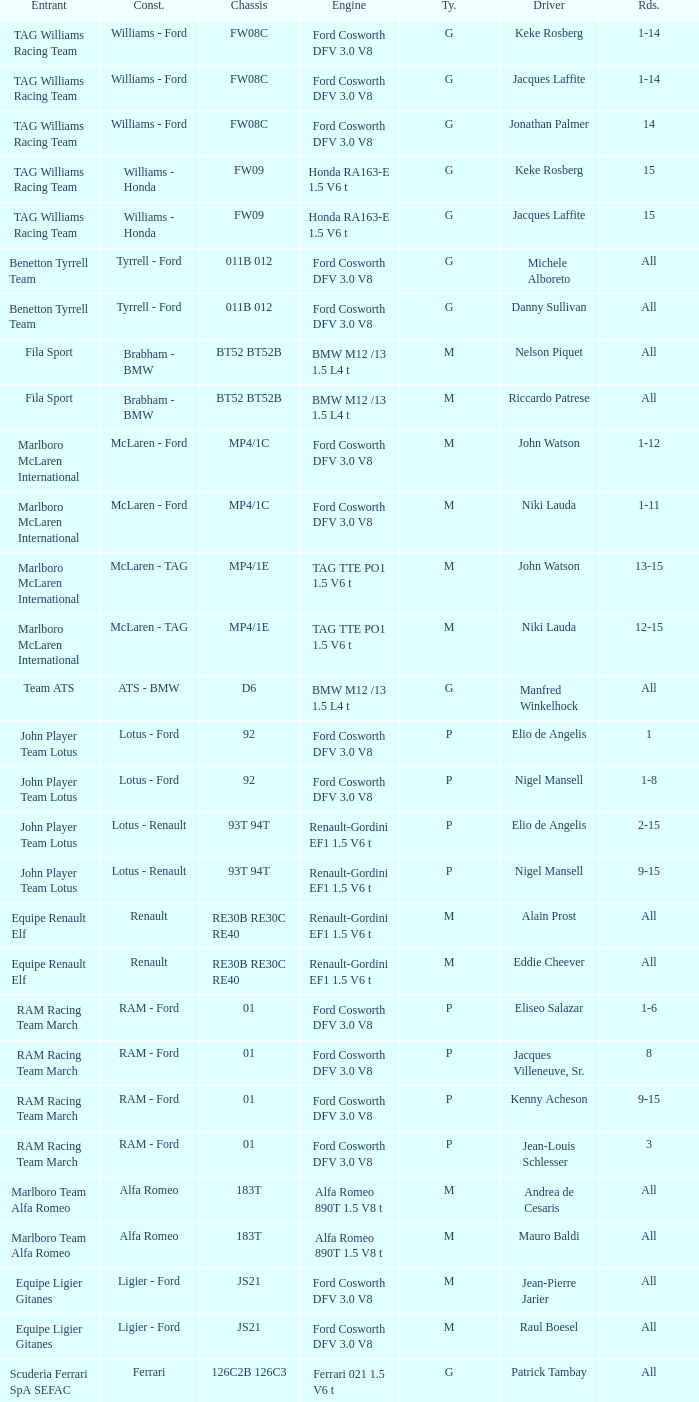Who is driver of the d6 chassis? Manfred Winkelhock. 